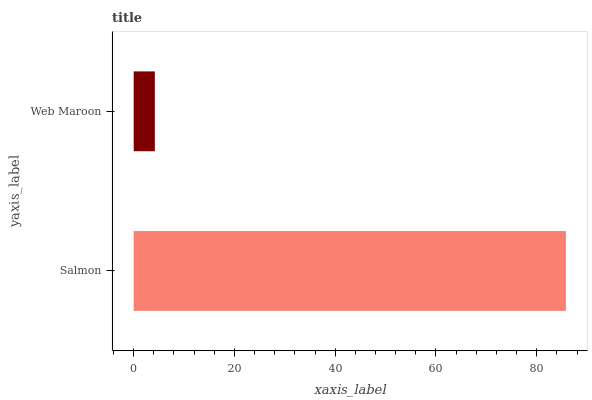Is Web Maroon the minimum?
Answer yes or no. Yes. Is Salmon the maximum?
Answer yes or no. Yes. Is Web Maroon the maximum?
Answer yes or no. No. Is Salmon greater than Web Maroon?
Answer yes or no. Yes. Is Web Maroon less than Salmon?
Answer yes or no. Yes. Is Web Maroon greater than Salmon?
Answer yes or no. No. Is Salmon less than Web Maroon?
Answer yes or no. No. Is Salmon the high median?
Answer yes or no. Yes. Is Web Maroon the low median?
Answer yes or no. Yes. Is Web Maroon the high median?
Answer yes or no. No. Is Salmon the low median?
Answer yes or no. No. 